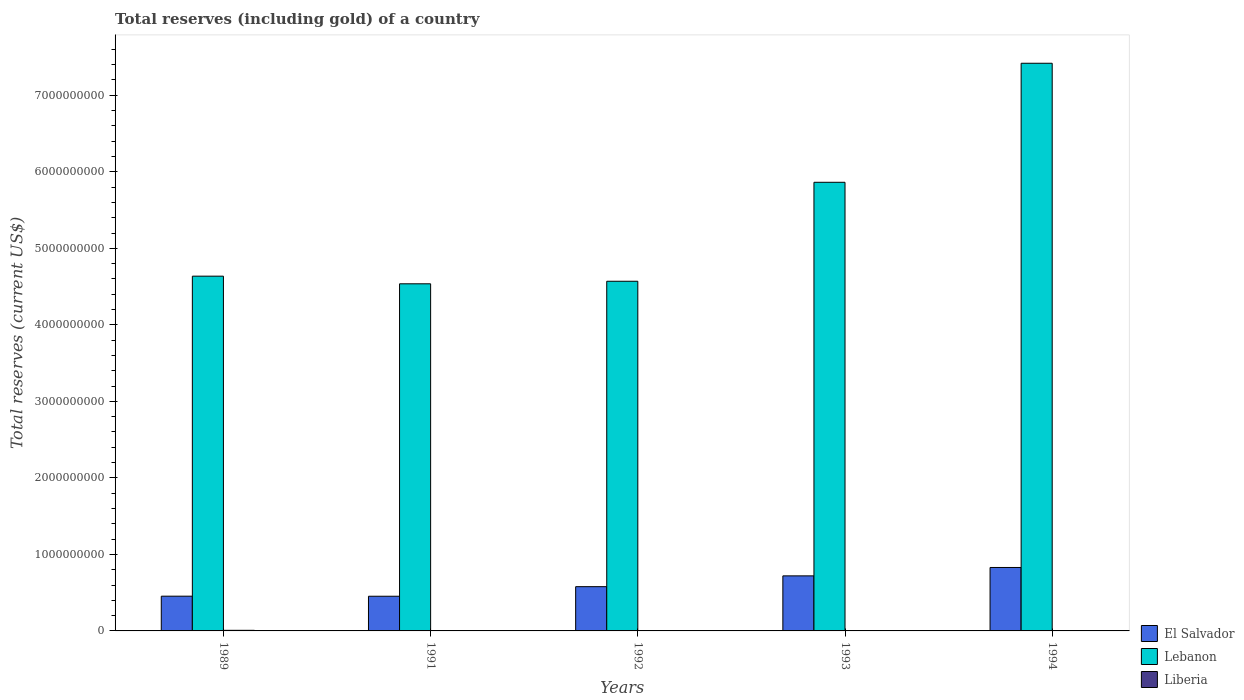How many different coloured bars are there?
Your answer should be very brief. 3. Are the number of bars per tick equal to the number of legend labels?
Make the answer very short. Yes. Are the number of bars on each tick of the X-axis equal?
Offer a very short reply. Yes. How many bars are there on the 4th tick from the left?
Offer a terse response. 3. In how many cases, is the number of bars for a given year not equal to the number of legend labels?
Your answer should be compact. 0. What is the total reserves (including gold) in Lebanon in 1989?
Offer a terse response. 4.64e+09. Across all years, what is the maximum total reserves (including gold) in Liberia?
Make the answer very short. 7.88e+06. Across all years, what is the minimum total reserves (including gold) in Lebanon?
Make the answer very short. 4.54e+09. In which year was the total reserves (including gold) in El Salvador maximum?
Make the answer very short. 1994. In which year was the total reserves (including gold) in Liberia minimum?
Offer a very short reply. 1992. What is the total total reserves (including gold) in Lebanon in the graph?
Ensure brevity in your answer.  2.70e+1. What is the difference between the total reserves (including gold) in El Salvador in 1991 and that in 1992?
Give a very brief answer. -1.25e+08. What is the difference between the total reserves (including gold) in Liberia in 1993 and the total reserves (including gold) in El Salvador in 1991?
Make the answer very short. -4.51e+08. What is the average total reserves (including gold) in Liberia per year?
Provide a short and direct response. 3.52e+06. In the year 1992, what is the difference between the total reserves (including gold) in El Salvador and total reserves (including gold) in Liberia?
Ensure brevity in your answer.  5.77e+08. What is the ratio of the total reserves (including gold) in Liberia in 1989 to that in 1994?
Your response must be concise. 1.55. Is the total reserves (including gold) in Liberia in 1989 less than that in 1994?
Provide a short and direct response. No. Is the difference between the total reserves (including gold) in El Salvador in 1989 and 1994 greater than the difference between the total reserves (including gold) in Liberia in 1989 and 1994?
Provide a succinct answer. No. What is the difference between the highest and the second highest total reserves (including gold) in Lebanon?
Provide a succinct answer. 1.56e+09. What is the difference between the highest and the lowest total reserves (including gold) in Lebanon?
Provide a short and direct response. 2.88e+09. In how many years, is the total reserves (including gold) in El Salvador greater than the average total reserves (including gold) in El Salvador taken over all years?
Provide a succinct answer. 2. Is the sum of the total reserves (including gold) in Liberia in 1989 and 1993 greater than the maximum total reserves (including gold) in Lebanon across all years?
Your response must be concise. No. What does the 3rd bar from the left in 1989 represents?
Make the answer very short. Liberia. What does the 3rd bar from the right in 1992 represents?
Make the answer very short. El Salvador. Are all the bars in the graph horizontal?
Your response must be concise. No. How many years are there in the graph?
Your answer should be compact. 5. What is the difference between two consecutive major ticks on the Y-axis?
Your answer should be compact. 1.00e+09. Are the values on the major ticks of Y-axis written in scientific E-notation?
Offer a terse response. No. Does the graph contain any zero values?
Your answer should be very brief. No. Does the graph contain grids?
Your response must be concise. No. How many legend labels are there?
Ensure brevity in your answer.  3. What is the title of the graph?
Your response must be concise. Total reserves (including gold) of a country. Does "Comoros" appear as one of the legend labels in the graph?
Make the answer very short. No. What is the label or title of the Y-axis?
Offer a very short reply. Total reserves (current US$). What is the Total reserves (current US$) in El Salvador in 1989?
Offer a terse response. 4.54e+08. What is the Total reserves (current US$) in Lebanon in 1989?
Provide a short and direct response. 4.64e+09. What is the Total reserves (current US$) of Liberia in 1989?
Give a very brief answer. 7.88e+06. What is the Total reserves (current US$) in El Salvador in 1991?
Give a very brief answer. 4.53e+08. What is the Total reserves (current US$) of Lebanon in 1991?
Your answer should be very brief. 4.54e+09. What is the Total reserves (current US$) in Liberia in 1991?
Keep it short and to the point. 1.31e+06. What is the Total reserves (current US$) in El Salvador in 1992?
Your answer should be very brief. 5.78e+08. What is the Total reserves (current US$) of Lebanon in 1992?
Keep it short and to the point. 4.57e+09. What is the Total reserves (current US$) of Liberia in 1992?
Make the answer very short. 9.77e+05. What is the Total reserves (current US$) of El Salvador in 1993?
Ensure brevity in your answer.  7.20e+08. What is the Total reserves (current US$) of Lebanon in 1993?
Offer a terse response. 5.86e+09. What is the Total reserves (current US$) of Liberia in 1993?
Give a very brief answer. 2.36e+06. What is the Total reserves (current US$) of El Salvador in 1994?
Give a very brief answer. 8.29e+08. What is the Total reserves (current US$) of Lebanon in 1994?
Keep it short and to the point. 7.42e+09. What is the Total reserves (current US$) of Liberia in 1994?
Make the answer very short. 5.07e+06. Across all years, what is the maximum Total reserves (current US$) of El Salvador?
Offer a terse response. 8.29e+08. Across all years, what is the maximum Total reserves (current US$) of Lebanon?
Keep it short and to the point. 7.42e+09. Across all years, what is the maximum Total reserves (current US$) of Liberia?
Offer a very short reply. 7.88e+06. Across all years, what is the minimum Total reserves (current US$) of El Salvador?
Give a very brief answer. 4.53e+08. Across all years, what is the minimum Total reserves (current US$) in Lebanon?
Ensure brevity in your answer.  4.54e+09. Across all years, what is the minimum Total reserves (current US$) in Liberia?
Offer a very short reply. 9.77e+05. What is the total Total reserves (current US$) of El Salvador in the graph?
Offer a terse response. 3.03e+09. What is the total Total reserves (current US$) in Lebanon in the graph?
Provide a short and direct response. 2.70e+1. What is the total Total reserves (current US$) of Liberia in the graph?
Make the answer very short. 1.76e+07. What is the difference between the Total reserves (current US$) in El Salvador in 1989 and that in 1991?
Make the answer very short. 9.53e+05. What is the difference between the Total reserves (current US$) of Lebanon in 1989 and that in 1991?
Your answer should be compact. 9.98e+07. What is the difference between the Total reserves (current US$) in Liberia in 1989 and that in 1991?
Offer a very short reply. 6.57e+06. What is the difference between the Total reserves (current US$) in El Salvador in 1989 and that in 1992?
Your answer should be very brief. -1.24e+08. What is the difference between the Total reserves (current US$) of Lebanon in 1989 and that in 1992?
Make the answer very short. 6.65e+07. What is the difference between the Total reserves (current US$) of Liberia in 1989 and that in 1992?
Make the answer very short. 6.90e+06. What is the difference between the Total reserves (current US$) in El Salvador in 1989 and that in 1993?
Provide a short and direct response. -2.65e+08. What is the difference between the Total reserves (current US$) in Lebanon in 1989 and that in 1993?
Offer a terse response. -1.23e+09. What is the difference between the Total reserves (current US$) of Liberia in 1989 and that in 1993?
Offer a very short reply. 5.51e+06. What is the difference between the Total reserves (current US$) in El Salvador in 1989 and that in 1994?
Your answer should be compact. -3.75e+08. What is the difference between the Total reserves (current US$) of Lebanon in 1989 and that in 1994?
Your answer should be compact. -2.78e+09. What is the difference between the Total reserves (current US$) of Liberia in 1989 and that in 1994?
Ensure brevity in your answer.  2.81e+06. What is the difference between the Total reserves (current US$) of El Salvador in 1991 and that in 1992?
Give a very brief answer. -1.25e+08. What is the difference between the Total reserves (current US$) in Lebanon in 1991 and that in 1992?
Your answer should be very brief. -3.33e+07. What is the difference between the Total reserves (current US$) of Liberia in 1991 and that in 1992?
Your response must be concise. 3.31e+05. What is the difference between the Total reserves (current US$) in El Salvador in 1991 and that in 1993?
Keep it short and to the point. -2.66e+08. What is the difference between the Total reserves (current US$) of Lebanon in 1991 and that in 1993?
Offer a very short reply. -1.33e+09. What is the difference between the Total reserves (current US$) of Liberia in 1991 and that in 1993?
Offer a very short reply. -1.05e+06. What is the difference between the Total reserves (current US$) of El Salvador in 1991 and that in 1994?
Make the answer very short. -3.76e+08. What is the difference between the Total reserves (current US$) of Lebanon in 1991 and that in 1994?
Ensure brevity in your answer.  -2.88e+09. What is the difference between the Total reserves (current US$) in Liberia in 1991 and that in 1994?
Provide a short and direct response. -3.76e+06. What is the difference between the Total reserves (current US$) of El Salvador in 1992 and that in 1993?
Keep it short and to the point. -1.41e+08. What is the difference between the Total reserves (current US$) of Lebanon in 1992 and that in 1993?
Provide a short and direct response. -1.29e+09. What is the difference between the Total reserves (current US$) of Liberia in 1992 and that in 1993?
Provide a short and direct response. -1.39e+06. What is the difference between the Total reserves (current US$) in El Salvador in 1992 and that in 1994?
Provide a short and direct response. -2.51e+08. What is the difference between the Total reserves (current US$) of Lebanon in 1992 and that in 1994?
Give a very brief answer. -2.85e+09. What is the difference between the Total reserves (current US$) of Liberia in 1992 and that in 1994?
Your answer should be very brief. -4.09e+06. What is the difference between the Total reserves (current US$) of El Salvador in 1993 and that in 1994?
Your response must be concise. -1.10e+08. What is the difference between the Total reserves (current US$) of Lebanon in 1993 and that in 1994?
Ensure brevity in your answer.  -1.56e+09. What is the difference between the Total reserves (current US$) of Liberia in 1993 and that in 1994?
Give a very brief answer. -2.71e+06. What is the difference between the Total reserves (current US$) in El Salvador in 1989 and the Total reserves (current US$) in Lebanon in 1991?
Keep it short and to the point. -4.08e+09. What is the difference between the Total reserves (current US$) of El Salvador in 1989 and the Total reserves (current US$) of Liberia in 1991?
Offer a very short reply. 4.53e+08. What is the difference between the Total reserves (current US$) of Lebanon in 1989 and the Total reserves (current US$) of Liberia in 1991?
Your answer should be very brief. 4.63e+09. What is the difference between the Total reserves (current US$) in El Salvador in 1989 and the Total reserves (current US$) in Lebanon in 1992?
Offer a terse response. -4.12e+09. What is the difference between the Total reserves (current US$) in El Salvador in 1989 and the Total reserves (current US$) in Liberia in 1992?
Offer a terse response. 4.53e+08. What is the difference between the Total reserves (current US$) of Lebanon in 1989 and the Total reserves (current US$) of Liberia in 1992?
Offer a terse response. 4.64e+09. What is the difference between the Total reserves (current US$) of El Salvador in 1989 and the Total reserves (current US$) of Lebanon in 1993?
Provide a succinct answer. -5.41e+09. What is the difference between the Total reserves (current US$) of El Salvador in 1989 and the Total reserves (current US$) of Liberia in 1993?
Your answer should be compact. 4.52e+08. What is the difference between the Total reserves (current US$) in Lebanon in 1989 and the Total reserves (current US$) in Liberia in 1993?
Your answer should be compact. 4.63e+09. What is the difference between the Total reserves (current US$) of El Salvador in 1989 and the Total reserves (current US$) of Lebanon in 1994?
Provide a short and direct response. -6.96e+09. What is the difference between the Total reserves (current US$) in El Salvador in 1989 and the Total reserves (current US$) in Liberia in 1994?
Keep it short and to the point. 4.49e+08. What is the difference between the Total reserves (current US$) of Lebanon in 1989 and the Total reserves (current US$) of Liberia in 1994?
Ensure brevity in your answer.  4.63e+09. What is the difference between the Total reserves (current US$) in El Salvador in 1991 and the Total reserves (current US$) in Lebanon in 1992?
Give a very brief answer. -4.12e+09. What is the difference between the Total reserves (current US$) in El Salvador in 1991 and the Total reserves (current US$) in Liberia in 1992?
Offer a very short reply. 4.52e+08. What is the difference between the Total reserves (current US$) of Lebanon in 1991 and the Total reserves (current US$) of Liberia in 1992?
Your answer should be very brief. 4.54e+09. What is the difference between the Total reserves (current US$) in El Salvador in 1991 and the Total reserves (current US$) in Lebanon in 1993?
Keep it short and to the point. -5.41e+09. What is the difference between the Total reserves (current US$) in El Salvador in 1991 and the Total reserves (current US$) in Liberia in 1993?
Offer a terse response. 4.51e+08. What is the difference between the Total reserves (current US$) of Lebanon in 1991 and the Total reserves (current US$) of Liberia in 1993?
Your answer should be very brief. 4.53e+09. What is the difference between the Total reserves (current US$) in El Salvador in 1991 and the Total reserves (current US$) in Lebanon in 1994?
Provide a succinct answer. -6.97e+09. What is the difference between the Total reserves (current US$) in El Salvador in 1991 and the Total reserves (current US$) in Liberia in 1994?
Provide a short and direct response. 4.48e+08. What is the difference between the Total reserves (current US$) in Lebanon in 1991 and the Total reserves (current US$) in Liberia in 1994?
Keep it short and to the point. 4.53e+09. What is the difference between the Total reserves (current US$) of El Salvador in 1992 and the Total reserves (current US$) of Lebanon in 1993?
Provide a succinct answer. -5.28e+09. What is the difference between the Total reserves (current US$) of El Salvador in 1992 and the Total reserves (current US$) of Liberia in 1993?
Your answer should be very brief. 5.76e+08. What is the difference between the Total reserves (current US$) of Lebanon in 1992 and the Total reserves (current US$) of Liberia in 1993?
Keep it short and to the point. 4.57e+09. What is the difference between the Total reserves (current US$) of El Salvador in 1992 and the Total reserves (current US$) of Lebanon in 1994?
Offer a terse response. -6.84e+09. What is the difference between the Total reserves (current US$) of El Salvador in 1992 and the Total reserves (current US$) of Liberia in 1994?
Your answer should be compact. 5.73e+08. What is the difference between the Total reserves (current US$) of Lebanon in 1992 and the Total reserves (current US$) of Liberia in 1994?
Offer a very short reply. 4.56e+09. What is the difference between the Total reserves (current US$) of El Salvador in 1993 and the Total reserves (current US$) of Lebanon in 1994?
Offer a very short reply. -6.70e+09. What is the difference between the Total reserves (current US$) in El Salvador in 1993 and the Total reserves (current US$) in Liberia in 1994?
Offer a terse response. 7.14e+08. What is the difference between the Total reserves (current US$) of Lebanon in 1993 and the Total reserves (current US$) of Liberia in 1994?
Offer a very short reply. 5.86e+09. What is the average Total reserves (current US$) in El Salvador per year?
Offer a very short reply. 6.07e+08. What is the average Total reserves (current US$) of Lebanon per year?
Your answer should be compact. 5.40e+09. What is the average Total reserves (current US$) in Liberia per year?
Offer a terse response. 3.52e+06. In the year 1989, what is the difference between the Total reserves (current US$) in El Salvador and Total reserves (current US$) in Lebanon?
Offer a terse response. -4.18e+09. In the year 1989, what is the difference between the Total reserves (current US$) in El Salvador and Total reserves (current US$) in Liberia?
Provide a succinct answer. 4.46e+08. In the year 1989, what is the difference between the Total reserves (current US$) in Lebanon and Total reserves (current US$) in Liberia?
Offer a terse response. 4.63e+09. In the year 1991, what is the difference between the Total reserves (current US$) in El Salvador and Total reserves (current US$) in Lebanon?
Give a very brief answer. -4.08e+09. In the year 1991, what is the difference between the Total reserves (current US$) in El Salvador and Total reserves (current US$) in Liberia?
Keep it short and to the point. 4.52e+08. In the year 1991, what is the difference between the Total reserves (current US$) of Lebanon and Total reserves (current US$) of Liberia?
Provide a short and direct response. 4.54e+09. In the year 1992, what is the difference between the Total reserves (current US$) in El Salvador and Total reserves (current US$) in Lebanon?
Ensure brevity in your answer.  -3.99e+09. In the year 1992, what is the difference between the Total reserves (current US$) in El Salvador and Total reserves (current US$) in Liberia?
Your response must be concise. 5.77e+08. In the year 1992, what is the difference between the Total reserves (current US$) in Lebanon and Total reserves (current US$) in Liberia?
Keep it short and to the point. 4.57e+09. In the year 1993, what is the difference between the Total reserves (current US$) in El Salvador and Total reserves (current US$) in Lebanon?
Keep it short and to the point. -5.14e+09. In the year 1993, what is the difference between the Total reserves (current US$) of El Salvador and Total reserves (current US$) of Liberia?
Offer a very short reply. 7.17e+08. In the year 1993, what is the difference between the Total reserves (current US$) of Lebanon and Total reserves (current US$) of Liberia?
Make the answer very short. 5.86e+09. In the year 1994, what is the difference between the Total reserves (current US$) in El Salvador and Total reserves (current US$) in Lebanon?
Your response must be concise. -6.59e+09. In the year 1994, what is the difference between the Total reserves (current US$) in El Salvador and Total reserves (current US$) in Liberia?
Provide a succinct answer. 8.24e+08. In the year 1994, what is the difference between the Total reserves (current US$) of Lebanon and Total reserves (current US$) of Liberia?
Provide a succinct answer. 7.41e+09. What is the ratio of the Total reserves (current US$) of Liberia in 1989 to that in 1991?
Offer a very short reply. 6.02. What is the ratio of the Total reserves (current US$) in El Salvador in 1989 to that in 1992?
Keep it short and to the point. 0.78. What is the ratio of the Total reserves (current US$) in Lebanon in 1989 to that in 1992?
Give a very brief answer. 1.01. What is the ratio of the Total reserves (current US$) of Liberia in 1989 to that in 1992?
Your answer should be very brief. 8.06. What is the ratio of the Total reserves (current US$) of El Salvador in 1989 to that in 1993?
Make the answer very short. 0.63. What is the ratio of the Total reserves (current US$) in Lebanon in 1989 to that in 1993?
Offer a terse response. 0.79. What is the ratio of the Total reserves (current US$) in Liberia in 1989 to that in 1993?
Your answer should be very brief. 3.33. What is the ratio of the Total reserves (current US$) in El Salvador in 1989 to that in 1994?
Keep it short and to the point. 0.55. What is the ratio of the Total reserves (current US$) of Lebanon in 1989 to that in 1994?
Ensure brevity in your answer.  0.62. What is the ratio of the Total reserves (current US$) in Liberia in 1989 to that in 1994?
Ensure brevity in your answer.  1.55. What is the ratio of the Total reserves (current US$) of El Salvador in 1991 to that in 1992?
Offer a terse response. 0.78. What is the ratio of the Total reserves (current US$) of Liberia in 1991 to that in 1992?
Provide a short and direct response. 1.34. What is the ratio of the Total reserves (current US$) in El Salvador in 1991 to that in 1993?
Provide a succinct answer. 0.63. What is the ratio of the Total reserves (current US$) in Lebanon in 1991 to that in 1993?
Provide a succinct answer. 0.77. What is the ratio of the Total reserves (current US$) in Liberia in 1991 to that in 1993?
Ensure brevity in your answer.  0.55. What is the ratio of the Total reserves (current US$) of El Salvador in 1991 to that in 1994?
Keep it short and to the point. 0.55. What is the ratio of the Total reserves (current US$) of Lebanon in 1991 to that in 1994?
Make the answer very short. 0.61. What is the ratio of the Total reserves (current US$) in Liberia in 1991 to that in 1994?
Your response must be concise. 0.26. What is the ratio of the Total reserves (current US$) in El Salvador in 1992 to that in 1993?
Offer a very short reply. 0.8. What is the ratio of the Total reserves (current US$) in Lebanon in 1992 to that in 1993?
Make the answer very short. 0.78. What is the ratio of the Total reserves (current US$) of Liberia in 1992 to that in 1993?
Keep it short and to the point. 0.41. What is the ratio of the Total reserves (current US$) of El Salvador in 1992 to that in 1994?
Offer a very short reply. 0.7. What is the ratio of the Total reserves (current US$) in Lebanon in 1992 to that in 1994?
Give a very brief answer. 0.62. What is the ratio of the Total reserves (current US$) of Liberia in 1992 to that in 1994?
Your response must be concise. 0.19. What is the ratio of the Total reserves (current US$) in El Salvador in 1993 to that in 1994?
Provide a succinct answer. 0.87. What is the ratio of the Total reserves (current US$) in Lebanon in 1993 to that in 1994?
Keep it short and to the point. 0.79. What is the ratio of the Total reserves (current US$) in Liberia in 1993 to that in 1994?
Offer a terse response. 0.47. What is the difference between the highest and the second highest Total reserves (current US$) of El Salvador?
Provide a short and direct response. 1.10e+08. What is the difference between the highest and the second highest Total reserves (current US$) in Lebanon?
Provide a succinct answer. 1.56e+09. What is the difference between the highest and the second highest Total reserves (current US$) of Liberia?
Offer a terse response. 2.81e+06. What is the difference between the highest and the lowest Total reserves (current US$) in El Salvador?
Provide a succinct answer. 3.76e+08. What is the difference between the highest and the lowest Total reserves (current US$) in Lebanon?
Ensure brevity in your answer.  2.88e+09. What is the difference between the highest and the lowest Total reserves (current US$) in Liberia?
Make the answer very short. 6.90e+06. 